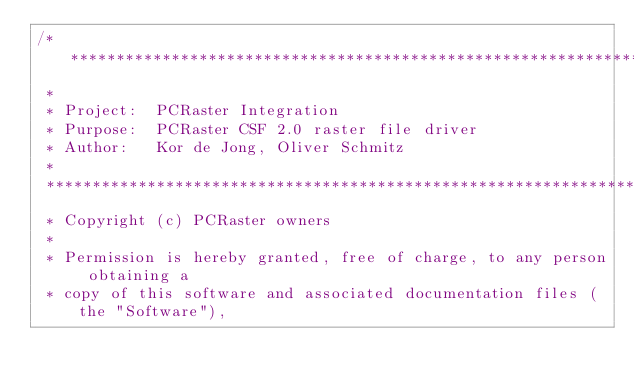Convert code to text. <code><loc_0><loc_0><loc_500><loc_500><_C++_>/******************************************************************************
 *
 * Project:  PCRaster Integration
 * Purpose:  PCRaster CSF 2.0 raster file driver
 * Author:   Kor de Jong, Oliver Schmitz
 *
 ******************************************************************************
 * Copyright (c) PCRaster owners
 *
 * Permission is hereby granted, free of charge, to any person obtaining a
 * copy of this software and associated documentation files (the "Software"),</code> 